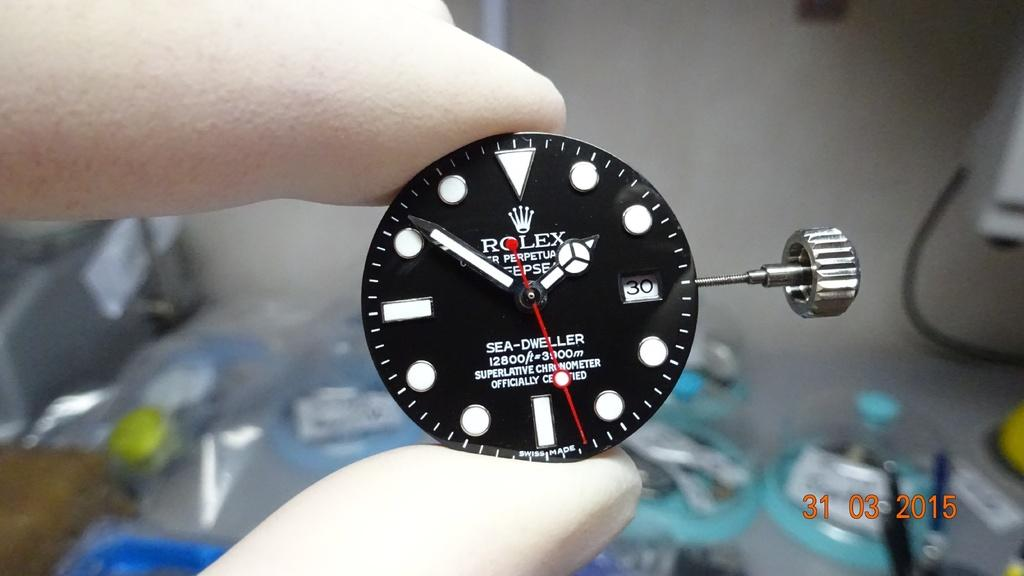Provide a one-sentence caption for the provided image. Someone wearing gloves is holding the face component of a Rolex wrist watch. 